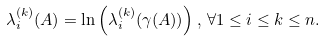Convert formula to latex. <formula><loc_0><loc_0><loc_500><loc_500>\lambda _ { i } ^ { ( k ) } ( A ) = \ln \left ( \lambda _ { i } ^ { ( k ) } ( \gamma ( A ) ) \right ) , \, \forall 1 \leq i \leq k \leq n .</formula> 